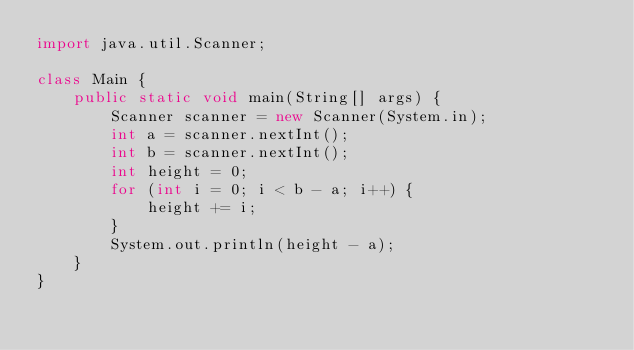<code> <loc_0><loc_0><loc_500><loc_500><_Java_>import java.util.Scanner;

class Main {
    public static void main(String[] args) {
        Scanner scanner = new Scanner(System.in);
        int a = scanner.nextInt();
        int b = scanner.nextInt();
        int height = 0;
        for (int i = 0; i < b - a; i++) {
            height += i;
        }
        System.out.println(height - a);
    }
}
</code> 